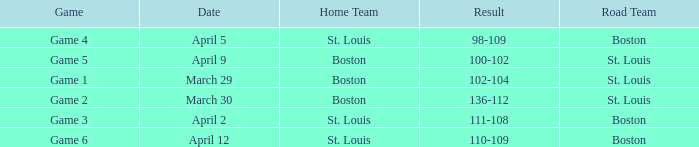What Game had a Result of 136-112? Game 2. 